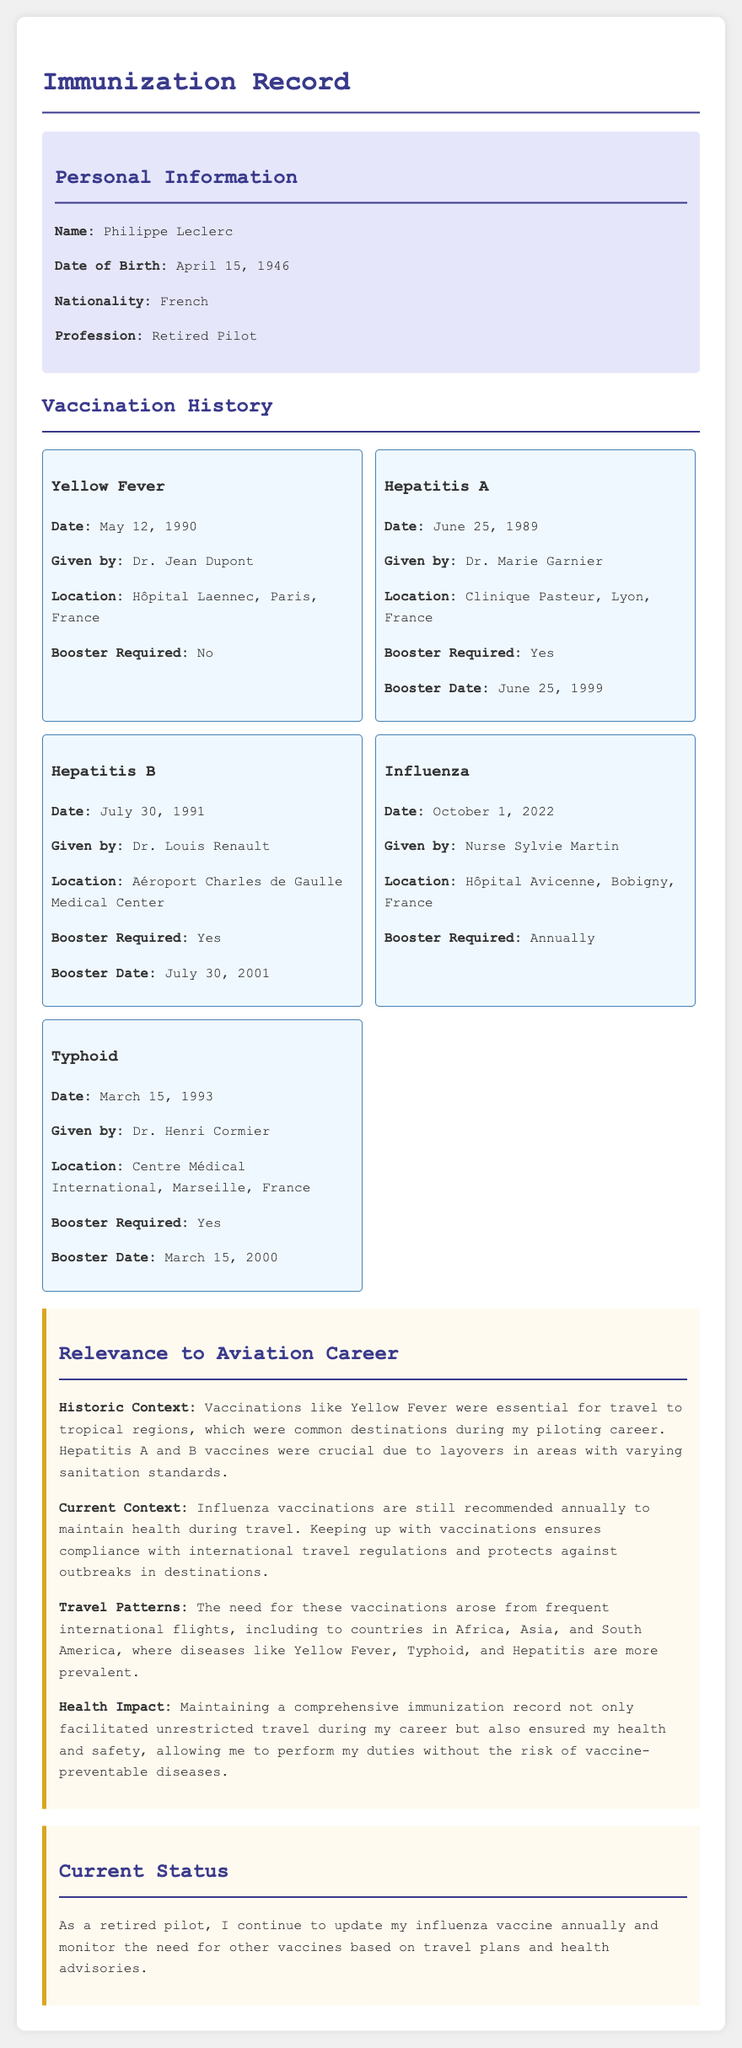What is the name of the individual? The document provides personal information highlighting the individual's name as Philippe Leclerc.
Answer: Philippe Leclerc What date was the Yellow Fever vaccine administered? According to the vaccination history, the date for the Yellow Fever vaccination is recorded.
Answer: May 12, 1990 Who administered the Hepatitis B vaccine? The document lists the name of the doctor who administered the Hepatitis B vaccine.
Answer: Dr. Louis Renault Is a booster required for Typhoid vaccination? The vaccination history indicates whether a booster is required for each vaccine.
Answer: Yes What is the current status of Philippe Leclerc's vaccinations? The current status section discusses how he continues to update his vaccinations.
Answer: Update annually How many years apart were the Hepatitis A vaccinations? The document states the initial and booster dates for Hepatitis A, which can be counted for the difference.
Answer: 10 years What is the significance of the vaccinations for Philippe's aviation career? The document describes the relevance of vaccinations to his profession, specifically for travel health.
Answer: Essential for travel Where was the Influenza vaccine administered? The vaccination history records the location where the Influenza vaccine was given.
Answer: Hôpital Avicenne, Bobigny, France What type of vaccine requires annual updates? The current status section discusses the need for certain vaccines to be updated regularly.
Answer: Influenza 